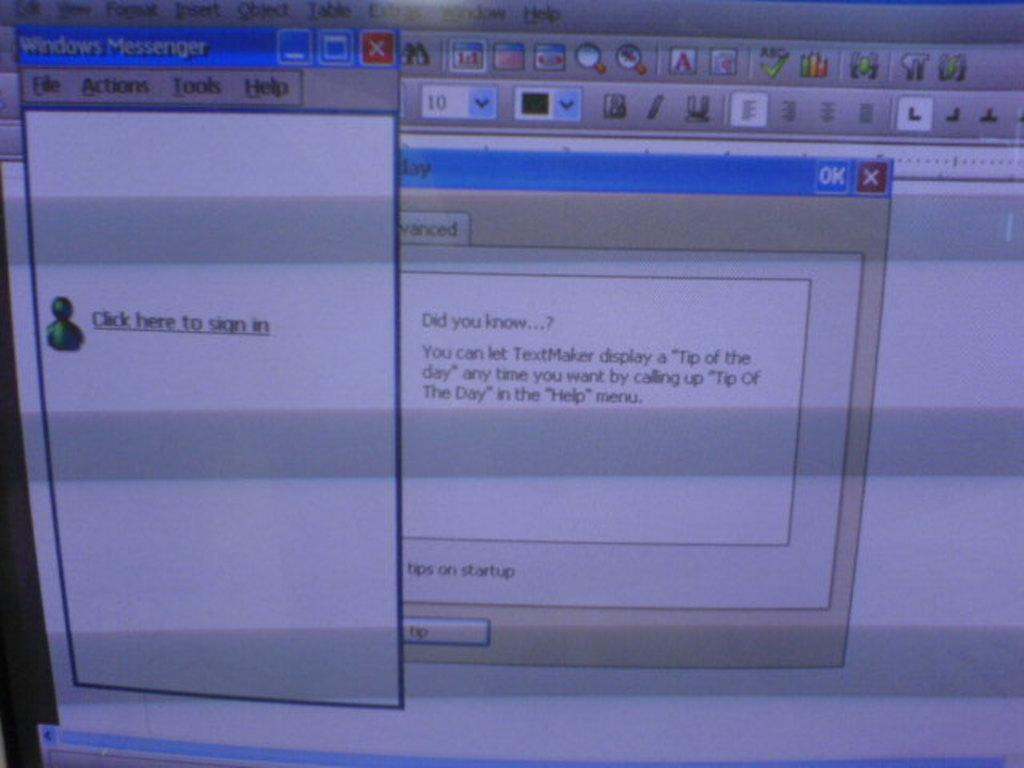Provide a one-sentence caption for the provided image. A Windows Messenger window tells the user to "click here to sign in". 